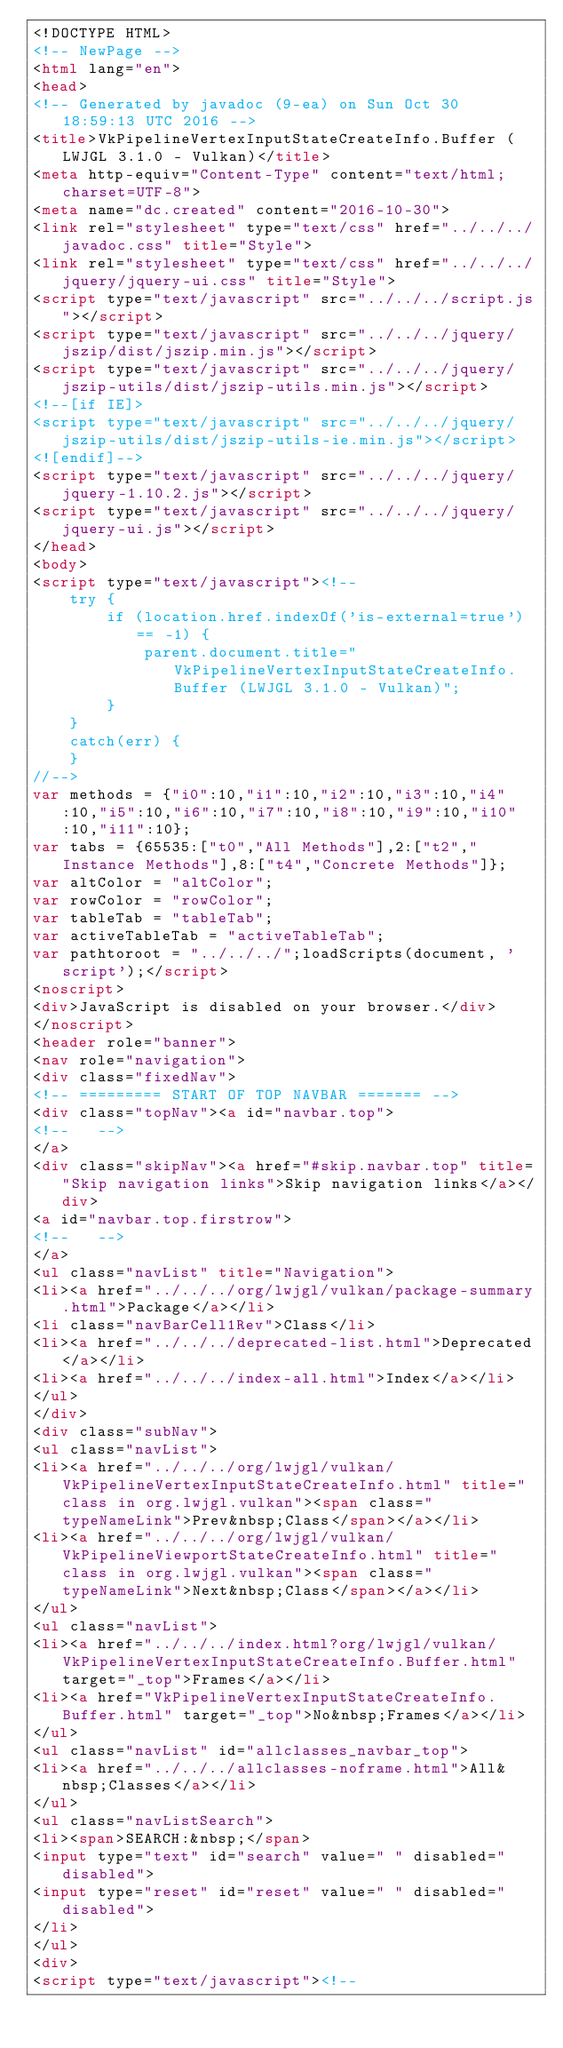<code> <loc_0><loc_0><loc_500><loc_500><_HTML_><!DOCTYPE HTML>
<!-- NewPage -->
<html lang="en">
<head>
<!-- Generated by javadoc (9-ea) on Sun Oct 30 18:59:13 UTC 2016 -->
<title>VkPipelineVertexInputStateCreateInfo.Buffer (LWJGL 3.1.0 - Vulkan)</title>
<meta http-equiv="Content-Type" content="text/html; charset=UTF-8">
<meta name="dc.created" content="2016-10-30">
<link rel="stylesheet" type="text/css" href="../../../javadoc.css" title="Style">
<link rel="stylesheet" type="text/css" href="../../../jquery/jquery-ui.css" title="Style">
<script type="text/javascript" src="../../../script.js"></script>
<script type="text/javascript" src="../../../jquery/jszip/dist/jszip.min.js"></script>
<script type="text/javascript" src="../../../jquery/jszip-utils/dist/jszip-utils.min.js"></script>
<!--[if IE]>
<script type="text/javascript" src="../../../jquery/jszip-utils/dist/jszip-utils-ie.min.js"></script>
<![endif]-->
<script type="text/javascript" src="../../../jquery/jquery-1.10.2.js"></script>
<script type="text/javascript" src="../../../jquery/jquery-ui.js"></script>
</head>
<body>
<script type="text/javascript"><!--
    try {
        if (location.href.indexOf('is-external=true') == -1) {
            parent.document.title="VkPipelineVertexInputStateCreateInfo.Buffer (LWJGL 3.1.0 - Vulkan)";
        }
    }
    catch(err) {
    }
//-->
var methods = {"i0":10,"i1":10,"i2":10,"i3":10,"i4":10,"i5":10,"i6":10,"i7":10,"i8":10,"i9":10,"i10":10,"i11":10};
var tabs = {65535:["t0","All Methods"],2:["t2","Instance Methods"],8:["t4","Concrete Methods"]};
var altColor = "altColor";
var rowColor = "rowColor";
var tableTab = "tableTab";
var activeTableTab = "activeTableTab";
var pathtoroot = "../../../";loadScripts(document, 'script');</script>
<noscript>
<div>JavaScript is disabled on your browser.</div>
</noscript>
<header role="banner">
<nav role="navigation">
<div class="fixedNav">
<!-- ========= START OF TOP NAVBAR ======= -->
<div class="topNav"><a id="navbar.top">
<!--   -->
</a>
<div class="skipNav"><a href="#skip.navbar.top" title="Skip navigation links">Skip navigation links</a></div>
<a id="navbar.top.firstrow">
<!--   -->
</a>
<ul class="navList" title="Navigation">
<li><a href="../../../org/lwjgl/vulkan/package-summary.html">Package</a></li>
<li class="navBarCell1Rev">Class</li>
<li><a href="../../../deprecated-list.html">Deprecated</a></li>
<li><a href="../../../index-all.html">Index</a></li>
</ul>
</div>
<div class="subNav">
<ul class="navList">
<li><a href="../../../org/lwjgl/vulkan/VkPipelineVertexInputStateCreateInfo.html" title="class in org.lwjgl.vulkan"><span class="typeNameLink">Prev&nbsp;Class</span></a></li>
<li><a href="../../../org/lwjgl/vulkan/VkPipelineViewportStateCreateInfo.html" title="class in org.lwjgl.vulkan"><span class="typeNameLink">Next&nbsp;Class</span></a></li>
</ul>
<ul class="navList">
<li><a href="../../../index.html?org/lwjgl/vulkan/VkPipelineVertexInputStateCreateInfo.Buffer.html" target="_top">Frames</a></li>
<li><a href="VkPipelineVertexInputStateCreateInfo.Buffer.html" target="_top">No&nbsp;Frames</a></li>
</ul>
<ul class="navList" id="allclasses_navbar_top">
<li><a href="../../../allclasses-noframe.html">All&nbsp;Classes</a></li>
</ul>
<ul class="navListSearch">
<li><span>SEARCH:&nbsp;</span>
<input type="text" id="search" value=" " disabled="disabled">
<input type="reset" id="reset" value=" " disabled="disabled">
</li>
</ul>
<div>
<script type="text/javascript"><!--</code> 